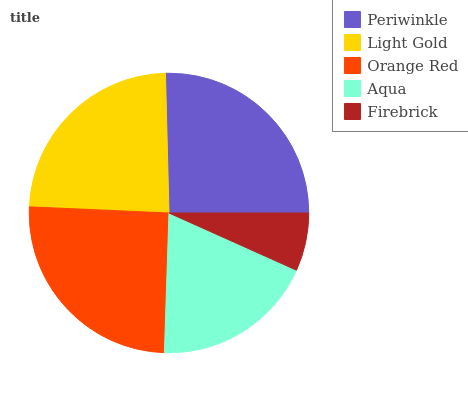Is Firebrick the minimum?
Answer yes or no. Yes. Is Periwinkle the maximum?
Answer yes or no. Yes. Is Light Gold the minimum?
Answer yes or no. No. Is Light Gold the maximum?
Answer yes or no. No. Is Periwinkle greater than Light Gold?
Answer yes or no. Yes. Is Light Gold less than Periwinkle?
Answer yes or no. Yes. Is Light Gold greater than Periwinkle?
Answer yes or no. No. Is Periwinkle less than Light Gold?
Answer yes or no. No. Is Light Gold the high median?
Answer yes or no. Yes. Is Light Gold the low median?
Answer yes or no. Yes. Is Aqua the high median?
Answer yes or no. No. Is Firebrick the low median?
Answer yes or no. No. 